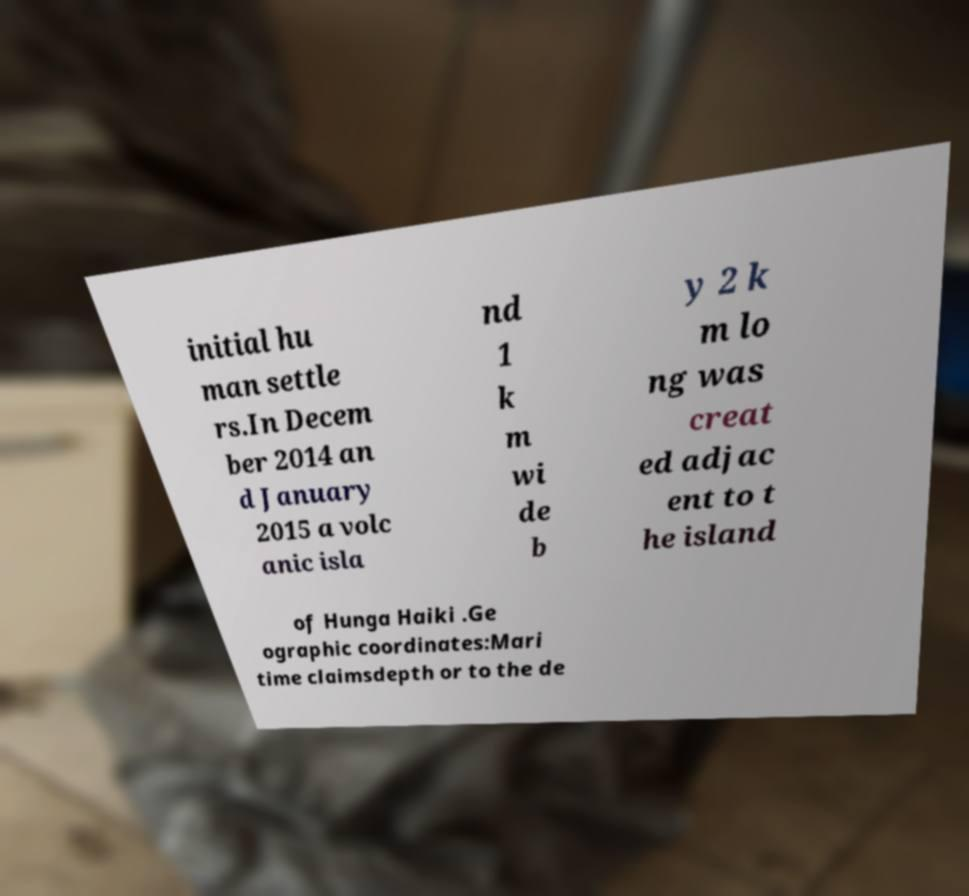Please read and relay the text visible in this image. What does it say? initial hu man settle rs.In Decem ber 2014 an d January 2015 a volc anic isla nd 1 k m wi de b y 2 k m lo ng was creat ed adjac ent to t he island of Hunga Haiki .Ge ographic coordinates:Mari time claimsdepth or to the de 